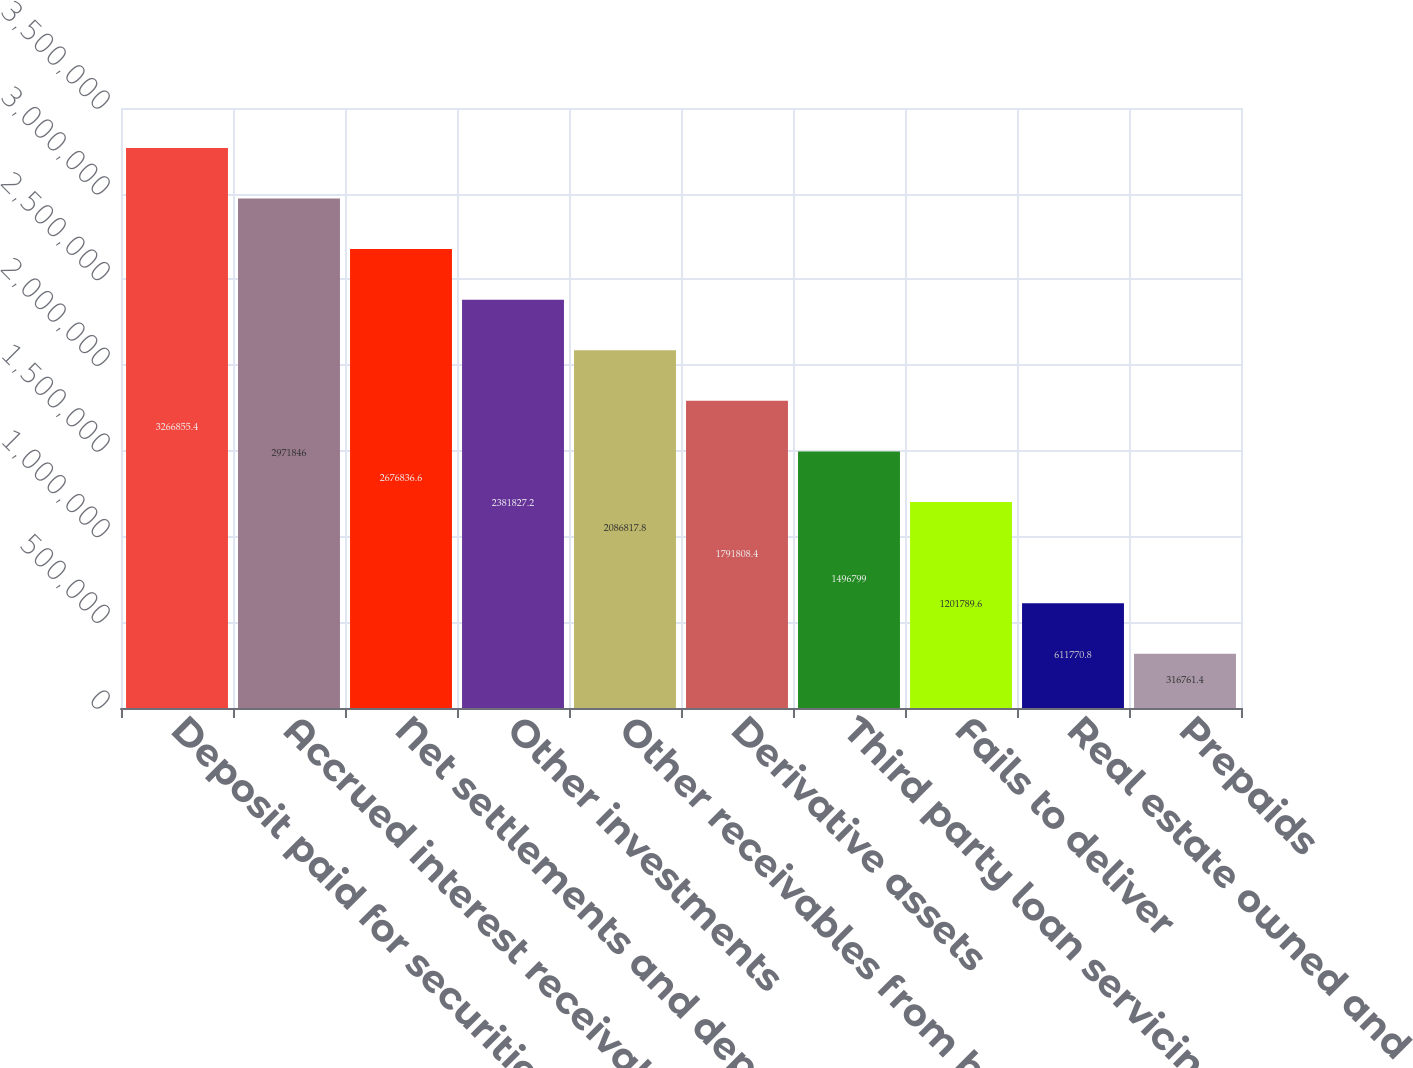<chart> <loc_0><loc_0><loc_500><loc_500><bar_chart><fcel>Deposit paid for securities<fcel>Accrued interest receivable<fcel>Net settlements and deposits<fcel>Other investments<fcel>Other receivables from brokers<fcel>Derivative assets<fcel>Third party loan servicing<fcel>Fails to deliver<fcel>Real estate owned and<fcel>Prepaids<nl><fcel>3.26686e+06<fcel>2.97185e+06<fcel>2.67684e+06<fcel>2.38183e+06<fcel>2.08682e+06<fcel>1.79181e+06<fcel>1.4968e+06<fcel>1.20179e+06<fcel>611771<fcel>316761<nl></chart> 